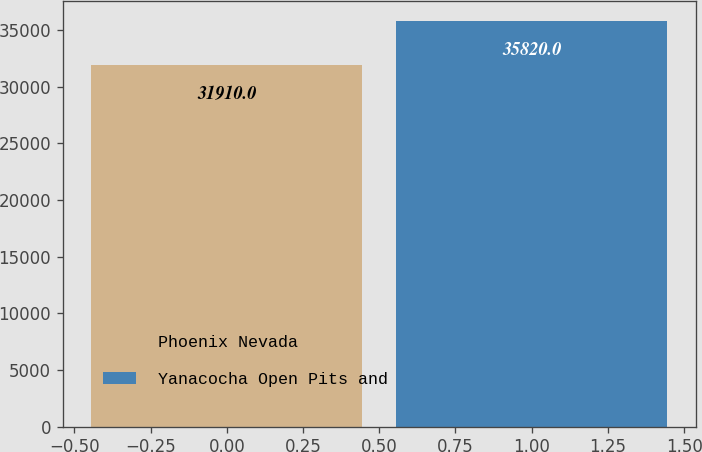<chart> <loc_0><loc_0><loc_500><loc_500><bar_chart><fcel>Phoenix Nevada<fcel>Yanacocha Open Pits and<nl><fcel>31910<fcel>35820<nl></chart> 